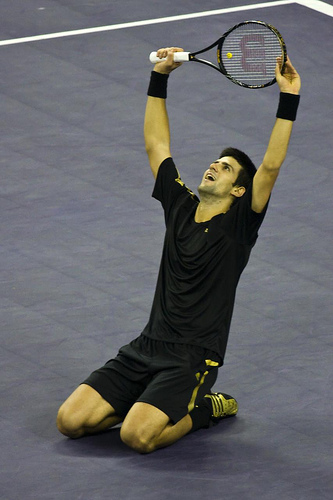Identify the text displayed in this image. w 